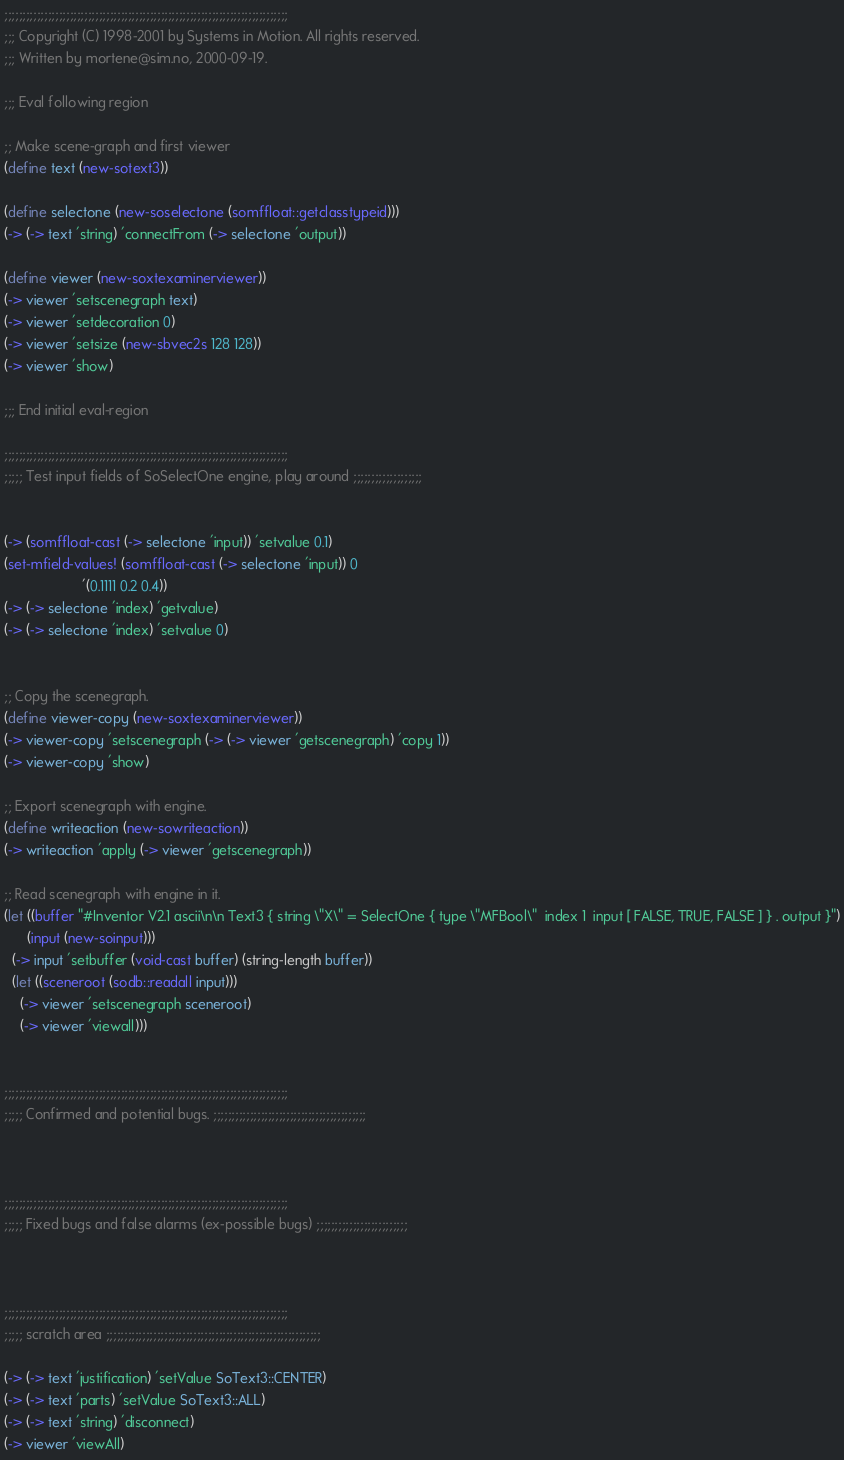Convert code to text. <code><loc_0><loc_0><loc_500><loc_500><_Scheme_>;;;;;;;;;;;;;;;;;;;;;;;;;;;;;;;;;;;;;;;;;;;;;;;;;;;;;;;;;;;;;;;;;;;;;;;;;;;;;;
;;; Copyright (C) 1998-2001 by Systems in Motion. All rights reserved.
;;; Written by mortene@sim.no, 2000-09-19.

;;; Eval following region

;; Make scene-graph and first viewer
(define text (new-sotext3))

(define selectone (new-soselectone (somffloat::getclasstypeid)))
(-> (-> text 'string) 'connectFrom (-> selectone 'output))

(define viewer (new-soxtexaminerviewer))
(-> viewer 'setscenegraph text)
(-> viewer 'setdecoration 0)
(-> viewer 'setsize (new-sbvec2s 128 128))
(-> viewer 'show)

;;; End initial eval-region

;;;;;;;;;;;;;;;;;;;;;;;;;;;;;;;;;;;;;;;;;;;;;;;;;;;;;;;;;;;;;;;;;;;;;;;;;;;;;;
;;;;; Test input fields of SoSelectOne engine, play around ;;;;;;;;;;;;;;;;;;;


(-> (somffloat-cast (-> selectone 'input)) 'setvalue 0.1)
(set-mfield-values! (somffloat-cast (-> selectone 'input)) 0
                    '(0.1111 0.2 0.4))
(-> (-> selectone 'index) 'getvalue)
(-> (-> selectone 'index) 'setvalue 0)
                    

;; Copy the scenegraph.
(define viewer-copy (new-soxtexaminerviewer))
(-> viewer-copy 'setscenegraph (-> (-> viewer 'getscenegraph) 'copy 1))
(-> viewer-copy 'show)

;; Export scenegraph with engine.
(define writeaction (new-sowriteaction))
(-> writeaction 'apply (-> viewer 'getscenegraph))

;; Read scenegraph with engine in it.
(let ((buffer "#Inventor V2.1 ascii\n\n Text3 { string \"X\" = SelectOne { type \"MFBool\"  index 1  input [ FALSE, TRUE, FALSE ] } . output }")
      (input (new-soinput)))
  (-> input 'setbuffer (void-cast buffer) (string-length buffer))
  (let ((sceneroot (sodb::readall input)))
    (-> viewer 'setscenegraph sceneroot)
    (-> viewer 'viewall)))


;;;;;;;;;;;;;;;;;;;;;;;;;;;;;;;;;;;;;;;;;;;;;;;;;;;;;;;;;;;;;;;;;;;;;;;;;;;;;;
;;;;; Confirmed and potential bugs. ;;;;;;;;;;;;;;;;;;;;;;;;;;;;;;;;;;;;;;;;;;



;;;;;;;;;;;;;;;;;;;;;;;;;;;;;;;;;;;;;;;;;;;;;;;;;;;;;;;;;;;;;;;;;;;;;;;;;;;;;;
;;;;; Fixed bugs and false alarms (ex-possible bugs) ;;;;;;;;;;;;;;;;;;;;;;;;;



;;;;;;;;;;;;;;;;;;;;;;;;;;;;;;;;;;;;;;;;;;;;;;;;;;;;;;;;;;;;;;;;;;;;;;;;;;;;;;
;;;;; scratch area ;;;;;;;;;;;;;;;;;;;;;;;;;;;;;;;;;;;;;;;;;;;;;;;;;;;;;;;;;;;

(-> (-> text 'justification) 'setValue SoText3::CENTER)
(-> (-> text 'parts) 'setValue SoText3::ALL)
(-> (-> text 'string) 'disconnect)
(-> viewer 'viewAll)
</code> 